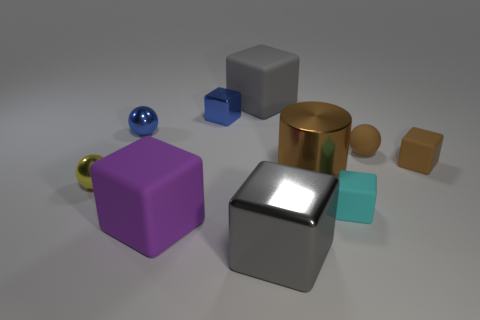What is the shape of the large metal object that is the same color as the tiny rubber ball?
Provide a succinct answer. Cylinder. Is there a small rubber cube?
Provide a succinct answer. Yes. There is a big gray object that is to the left of the big gray shiny object; is it the same shape as the gray metal object that is left of the metal cylinder?
Offer a very short reply. Yes. What number of big things are either purple matte cylinders or blue metal objects?
Provide a short and direct response. 0. The brown object that is made of the same material as the brown cube is what shape?
Keep it short and to the point. Sphere. Is the large brown object the same shape as the purple matte thing?
Provide a succinct answer. No. The large cylinder is what color?
Offer a very short reply. Brown. How many objects are blue spheres or purple matte blocks?
Your answer should be very brief. 2. Are there fewer large matte cubes in front of the small yellow ball than small blue rubber objects?
Keep it short and to the point. No. Is the number of large matte things to the left of the big gray rubber thing greater than the number of small brown matte cubes behind the small brown sphere?
Your response must be concise. Yes. 